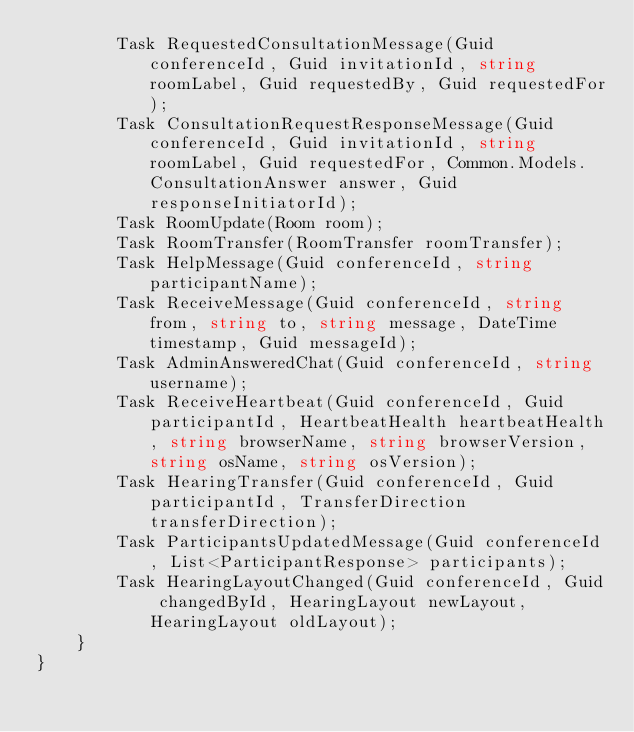Convert code to text. <code><loc_0><loc_0><loc_500><loc_500><_C#_>        Task RequestedConsultationMessage(Guid conferenceId, Guid invitationId, string roomLabel, Guid requestedBy, Guid requestedFor);
        Task ConsultationRequestResponseMessage(Guid conferenceId, Guid invitationId, string roomLabel, Guid requestedFor, Common.Models.ConsultationAnswer answer, Guid responseInitiatorId);
        Task RoomUpdate(Room room);
        Task RoomTransfer(RoomTransfer roomTransfer);
        Task HelpMessage(Guid conferenceId, string participantName);
        Task ReceiveMessage(Guid conferenceId, string from, string to, string message, DateTime timestamp, Guid messageId);
        Task AdminAnsweredChat(Guid conferenceId, string username);
        Task ReceiveHeartbeat(Guid conferenceId, Guid participantId, HeartbeatHealth heartbeatHealth, string browserName, string browserVersion, string osName, string osVersion);
        Task HearingTransfer(Guid conferenceId, Guid participantId, TransferDirection transferDirection);
        Task ParticipantsUpdatedMessage(Guid conferenceId, List<ParticipantResponse> participants);
        Task HearingLayoutChanged(Guid conferenceId, Guid changedById, HearingLayout newLayout, HearingLayout oldLayout);
    }
}
</code> 